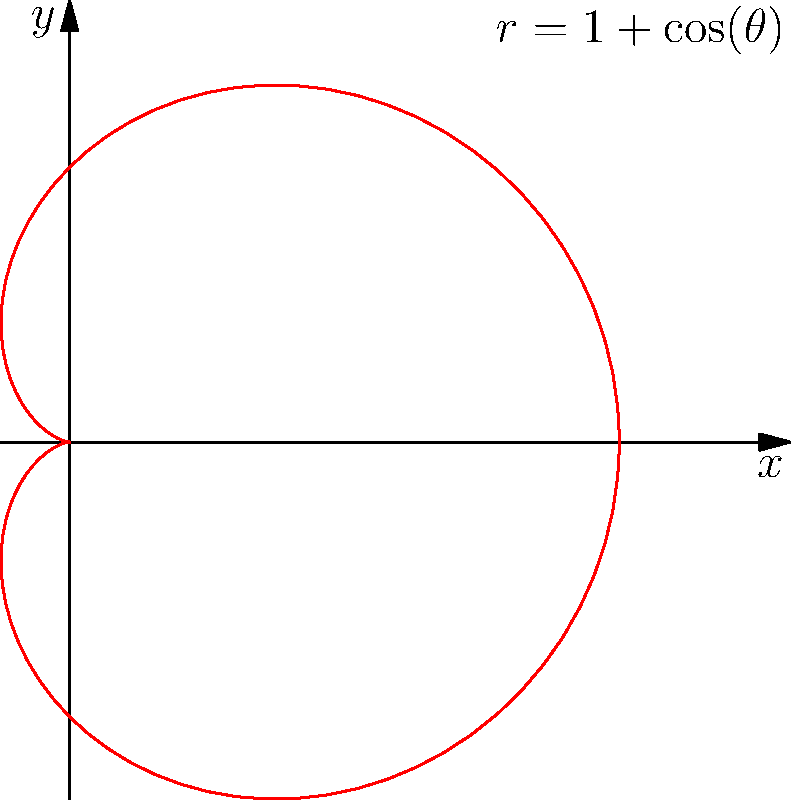Consider the cardioid given by the polar equation $r = 1 + \cos(\theta)$. Using the integration technique for polar coordinates, calculate the area enclosed by this curve. Express your answer in terms of $\pi$. Let's approach this step-by-step:

1) The general formula for the area enclosed by a polar curve is:
   $$A = \frac{1}{2} \int_{0}^{2\pi} r^2(\theta) d\theta$$

2) In our case, $r(\theta) = 1 + \cos(\theta)$. We need to square this:
   $$r^2(\theta) = (1 + \cos(\theta))^2 = 1 + 2\cos(\theta) + \cos^2(\theta)$$

3) Now, let's set up our integral:
   $$A = \frac{1}{2} \int_{0}^{2\pi} (1 + 2\cos(\theta) + \cos^2(\theta)) d\theta$$

4) We can split this into three integrals:
   $$A = \frac{1}{2} \left[ \int_{0}^{2\pi} 1 d\theta + 2\int_{0}^{2\pi} \cos(\theta) d\theta + \int_{0}^{2\pi} \cos^2(\theta) d\theta \right]$$

5) Let's evaluate each integral:
   - $\int_{0}^{2\pi} 1 d\theta = 2\pi$
   - $\int_{0}^{2\pi} \cos(\theta) d\theta = [\sin(\theta)]_{0}^{2\pi} = 0$
   - For the last integral, we can use the identity $\cos^2(\theta) = \frac{1}{2}(1 + \cos(2\theta))$:
     $\int_{0}^{2\pi} \cos^2(\theta) d\theta = \int_{0}^{2\pi} \frac{1}{2}(1 + \cos(2\theta)) d\theta = \pi + 0 = \pi$

6) Substituting these back:
   $$A = \frac{1}{2} (2\pi + 0 + \pi) = \frac{3\pi}{2}$$

Therefore, the area enclosed by the cardioid is $\frac{3\pi}{2}$.
Answer: $\frac{3\pi}{2}$ 